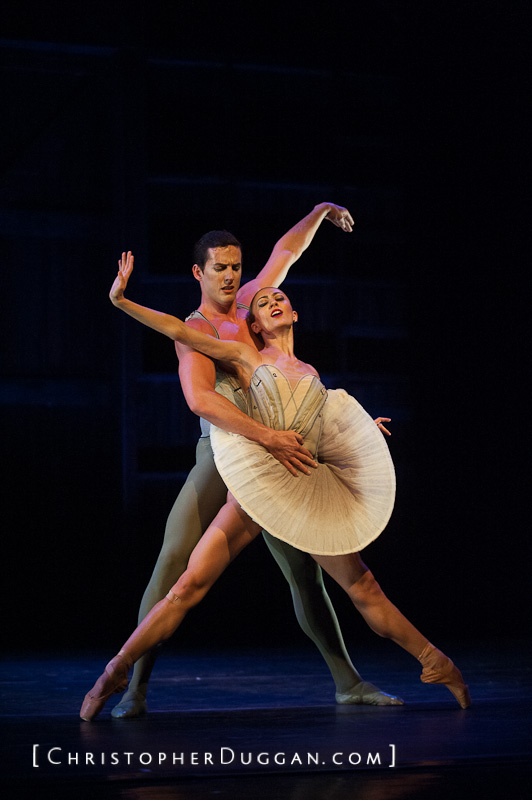What do the costumes of the dancers tell us about the setting or theme of the dance? The costumes of the dancers provide significant insights into the setting and theme of the performance. The male dancer is dressed in simple, tight-fitting attire, highlighting his strength, support, and agility, whereas the female dancer wears a classic tutu, indicative of a traditional ballet piece. Her elegant dress, coupled with its light color, suggests purity, grace, and a certain timelessness. This choice in costuming implies a historical or classical theme, possibly set in a romantic era or timeless narrative, emphasizing elegance, tradition, and the beauty of classical ballet. How do the lighting and staging contribute to the overall mood of this performance? The lighting and staging play crucial roles in setting the mood for this performance. The dark, subdued background and spotlight on the dancers create a strong contrast that draws the audience’s focus to their movements and expressions. The warm, focused lighting highlights their graceful postures and elegant costumes, adding a layer of intimacy and drama to the scene. This setup enhances the emotions conveyed through their body language, emphasizing themes of romance, connection, and elegance, while the dark ambiance around them adds a sense of mystery and depth, inviting the audience to become absorbed in the narrative. 